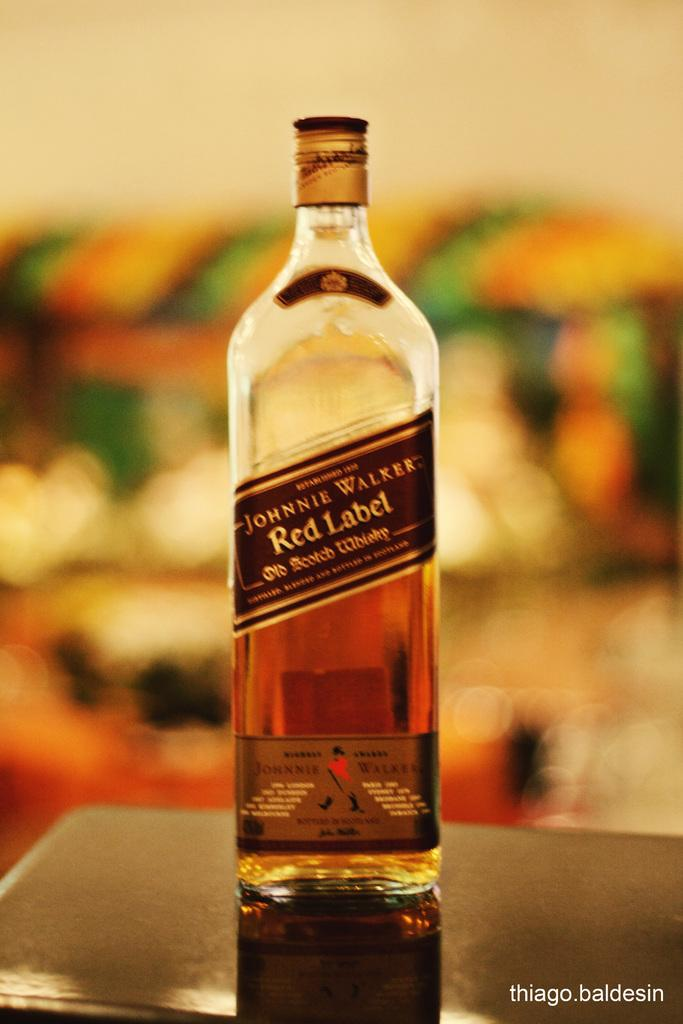What object can be seen in the image? There is a bottle in the image. How many cherries are on the bed in the image? There is no mention of cherries or a bed in the image; it only features a bottle. 